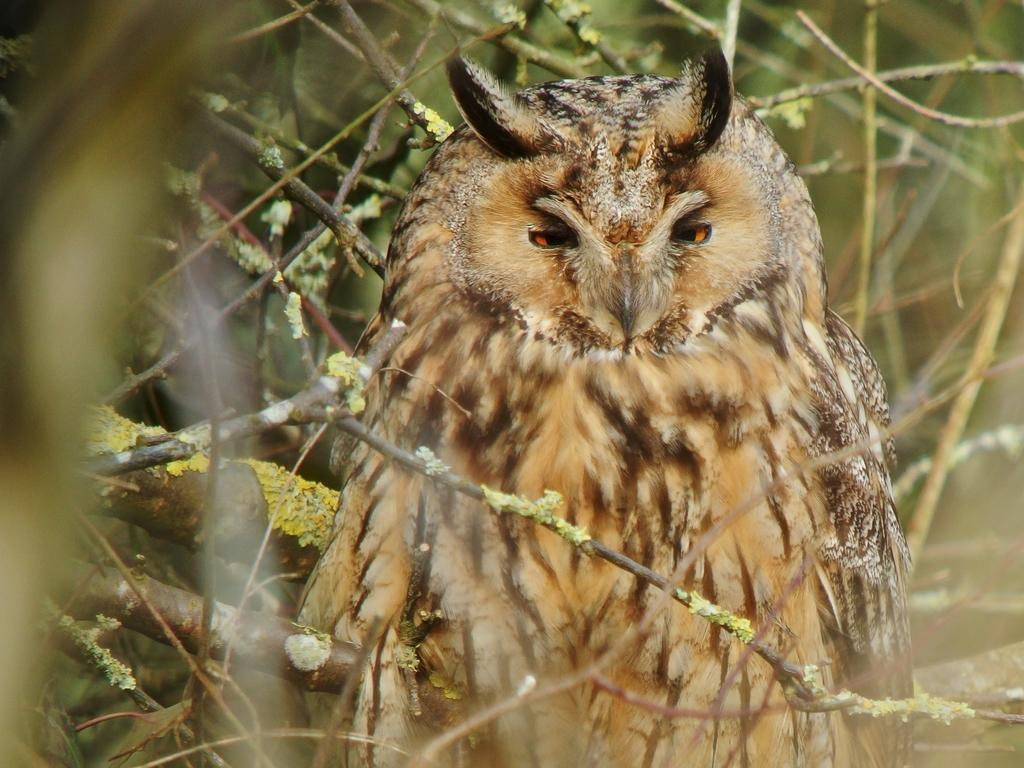What type of animal can be seen in the image? There is a bird in the image. What is the bird perched on in the image? The bird is perched on branches of trees in the image. What type of power source is visible in the image? There is no power source visible in the image; it features a bird perched on branches of trees. 